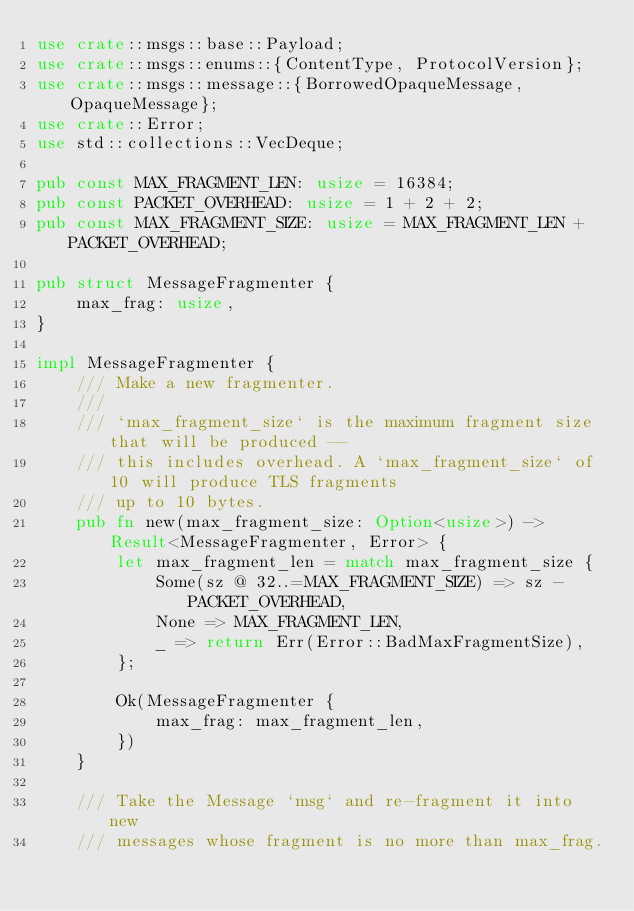Convert code to text. <code><loc_0><loc_0><loc_500><loc_500><_Rust_>use crate::msgs::base::Payload;
use crate::msgs::enums::{ContentType, ProtocolVersion};
use crate::msgs::message::{BorrowedOpaqueMessage, OpaqueMessage};
use crate::Error;
use std::collections::VecDeque;

pub const MAX_FRAGMENT_LEN: usize = 16384;
pub const PACKET_OVERHEAD: usize = 1 + 2 + 2;
pub const MAX_FRAGMENT_SIZE: usize = MAX_FRAGMENT_LEN + PACKET_OVERHEAD;

pub struct MessageFragmenter {
    max_frag: usize,
}

impl MessageFragmenter {
    /// Make a new fragmenter.
    ///
    /// `max_fragment_size` is the maximum fragment size that will be produced --
    /// this includes overhead. A `max_fragment_size` of 10 will produce TLS fragments
    /// up to 10 bytes.
    pub fn new(max_fragment_size: Option<usize>) -> Result<MessageFragmenter, Error> {
        let max_fragment_len = match max_fragment_size {
            Some(sz @ 32..=MAX_FRAGMENT_SIZE) => sz - PACKET_OVERHEAD,
            None => MAX_FRAGMENT_LEN,
            _ => return Err(Error::BadMaxFragmentSize),
        };

        Ok(MessageFragmenter {
            max_frag: max_fragment_len,
        })
    }

    /// Take the Message `msg` and re-fragment it into new
    /// messages whose fragment is no more than max_frag.</code> 